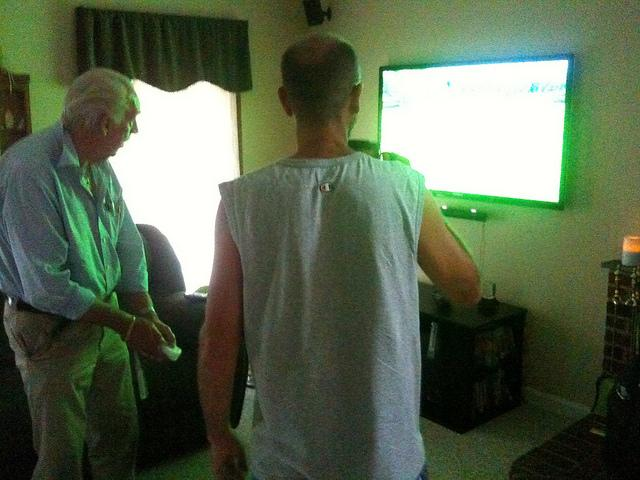Which sport is the man on the left most likely playing on the nintendo wii appliance? golf 